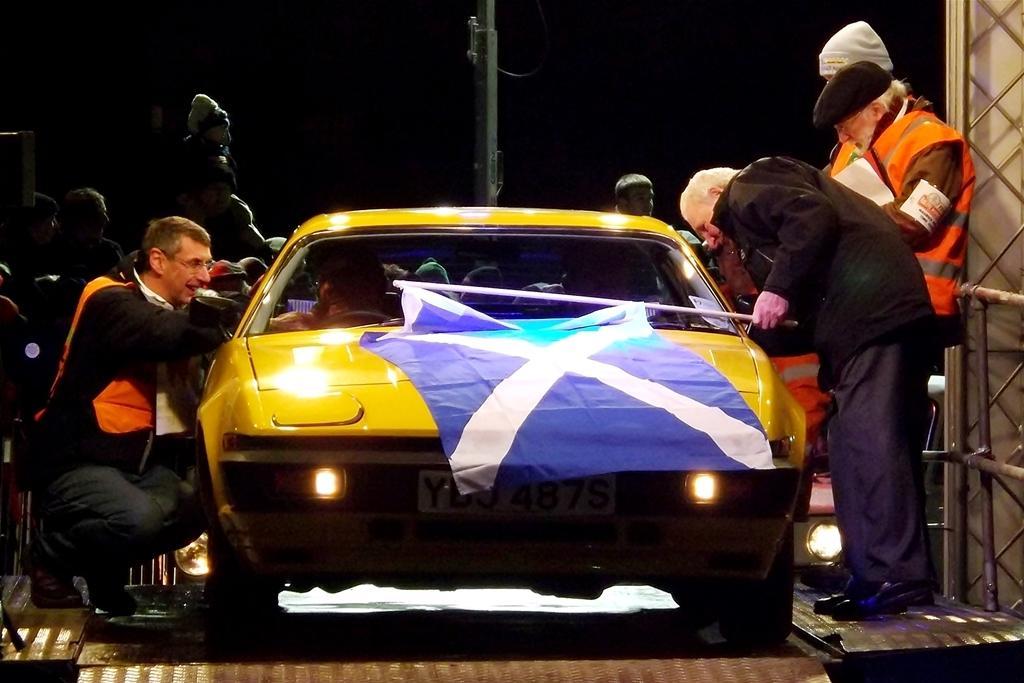In one or two sentences, can you explain what this image depicts? In this image I can see the vehicle in yellow color and I can see few people standing. In front the person is holding the flag and I can see the dark background. 